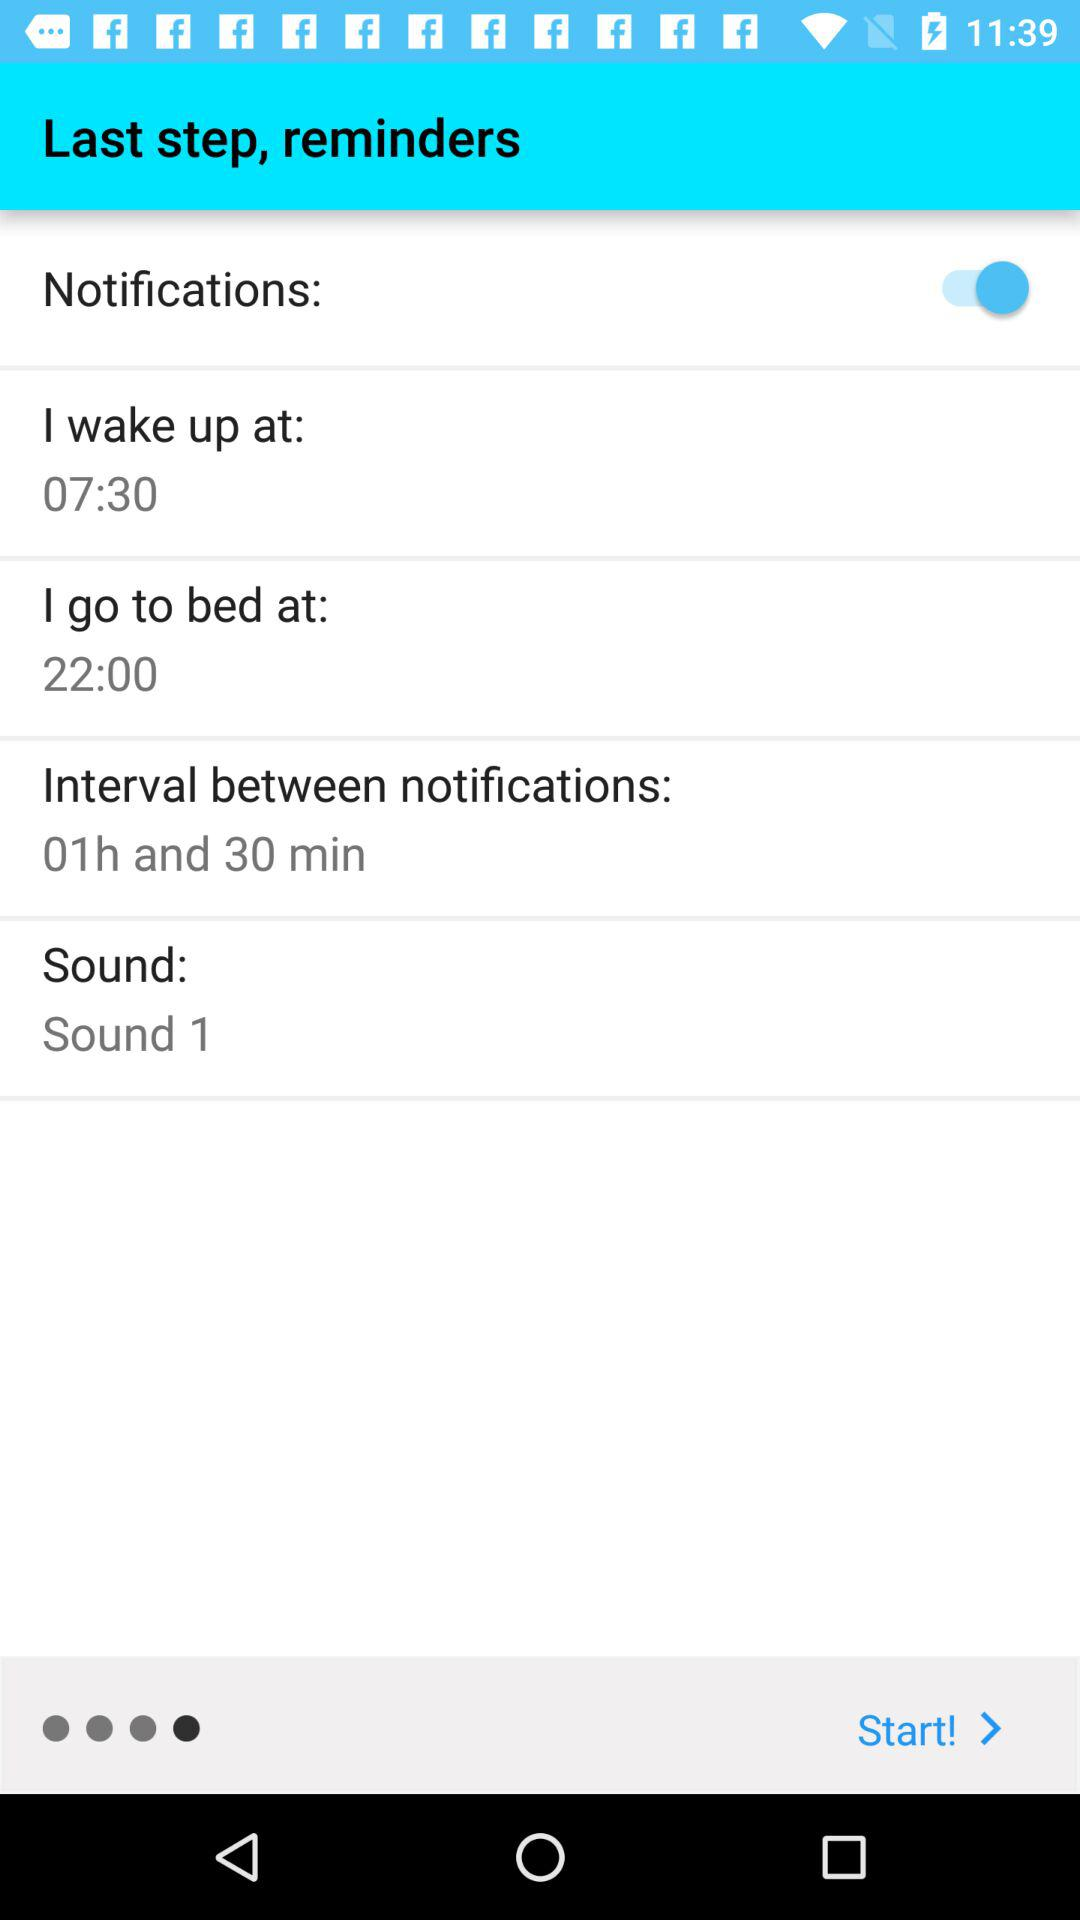What is the wake-up time? The wake-up time is 07:30. 